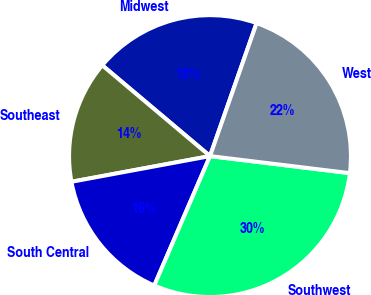<chart> <loc_0><loc_0><loc_500><loc_500><pie_chart><fcel>Midwest<fcel>Southeast<fcel>South Central<fcel>Southwest<fcel>West<nl><fcel>19.22%<fcel>14.06%<fcel>15.61%<fcel>29.54%<fcel>21.57%<nl></chart> 